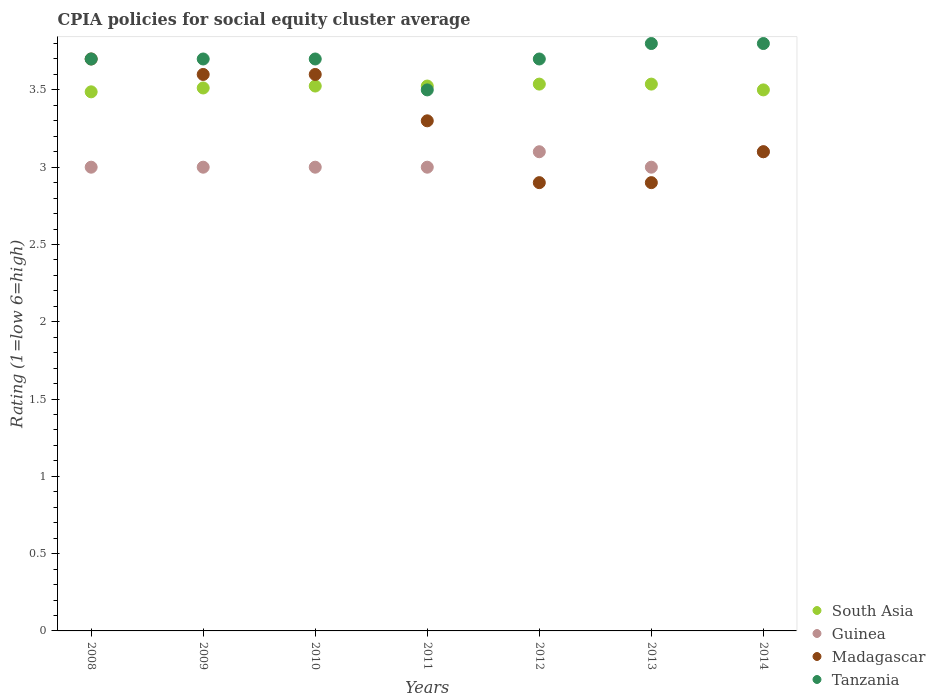Is the number of dotlines equal to the number of legend labels?
Offer a terse response. Yes. What is the CPIA rating in Tanzania in 2013?
Provide a succinct answer. 3.8. Across all years, what is the maximum CPIA rating in Tanzania?
Provide a succinct answer. 3.8. What is the total CPIA rating in Guinea in the graph?
Provide a short and direct response. 21.2. What is the difference between the CPIA rating in Madagascar in 2008 and that in 2010?
Give a very brief answer. 0.1. What is the difference between the CPIA rating in Madagascar in 2014 and the CPIA rating in Guinea in 2009?
Your response must be concise. 0.1. What is the average CPIA rating in Tanzania per year?
Your response must be concise. 3.7. In the year 2013, what is the difference between the CPIA rating in Madagascar and CPIA rating in South Asia?
Make the answer very short. -0.64. In how many years, is the CPIA rating in Madagascar greater than 3.3?
Give a very brief answer. 3. What is the ratio of the CPIA rating in Guinea in 2009 to that in 2012?
Offer a terse response. 0.97. Is the CPIA rating in Tanzania in 2010 less than that in 2012?
Keep it short and to the point. No. Is the difference between the CPIA rating in Madagascar in 2011 and 2013 greater than the difference between the CPIA rating in South Asia in 2011 and 2013?
Provide a succinct answer. Yes. What is the difference between the highest and the second highest CPIA rating in Madagascar?
Your response must be concise. 0.1. What is the difference between the highest and the lowest CPIA rating in Tanzania?
Make the answer very short. 0.3. In how many years, is the CPIA rating in Guinea greater than the average CPIA rating in Guinea taken over all years?
Offer a very short reply. 2. Is the sum of the CPIA rating in Madagascar in 2008 and 2010 greater than the maximum CPIA rating in Tanzania across all years?
Keep it short and to the point. Yes. Does the CPIA rating in South Asia monotonically increase over the years?
Your response must be concise. No. Is the CPIA rating in Guinea strictly less than the CPIA rating in Madagascar over the years?
Ensure brevity in your answer.  No. How many dotlines are there?
Your answer should be compact. 4. What is the difference between two consecutive major ticks on the Y-axis?
Make the answer very short. 0.5. Are the values on the major ticks of Y-axis written in scientific E-notation?
Provide a short and direct response. No. Where does the legend appear in the graph?
Make the answer very short. Bottom right. What is the title of the graph?
Make the answer very short. CPIA policies for social equity cluster average. Does "Low & middle income" appear as one of the legend labels in the graph?
Your response must be concise. No. What is the label or title of the X-axis?
Make the answer very short. Years. What is the label or title of the Y-axis?
Ensure brevity in your answer.  Rating (1=low 6=high). What is the Rating (1=low 6=high) in South Asia in 2008?
Provide a succinct answer. 3.49. What is the Rating (1=low 6=high) in Tanzania in 2008?
Your answer should be compact. 3.7. What is the Rating (1=low 6=high) in South Asia in 2009?
Keep it short and to the point. 3.51. What is the Rating (1=low 6=high) of Guinea in 2009?
Keep it short and to the point. 3. What is the Rating (1=low 6=high) in South Asia in 2010?
Make the answer very short. 3.52. What is the Rating (1=low 6=high) of Guinea in 2010?
Keep it short and to the point. 3. What is the Rating (1=low 6=high) of Tanzania in 2010?
Make the answer very short. 3.7. What is the Rating (1=low 6=high) in South Asia in 2011?
Your answer should be very brief. 3.52. What is the Rating (1=low 6=high) of Tanzania in 2011?
Your answer should be compact. 3.5. What is the Rating (1=low 6=high) of South Asia in 2012?
Offer a very short reply. 3.54. What is the Rating (1=low 6=high) of Guinea in 2012?
Your answer should be compact. 3.1. What is the Rating (1=low 6=high) in Madagascar in 2012?
Keep it short and to the point. 2.9. What is the Rating (1=low 6=high) in South Asia in 2013?
Your answer should be very brief. 3.54. What is the Rating (1=low 6=high) of Guinea in 2013?
Keep it short and to the point. 3. What is the Rating (1=low 6=high) in Madagascar in 2013?
Offer a very short reply. 2.9. What is the Rating (1=low 6=high) of Tanzania in 2013?
Your answer should be compact. 3.8. What is the Rating (1=low 6=high) in Madagascar in 2014?
Offer a terse response. 3.1. What is the Rating (1=low 6=high) in Tanzania in 2014?
Give a very brief answer. 3.8. Across all years, what is the maximum Rating (1=low 6=high) in South Asia?
Give a very brief answer. 3.54. Across all years, what is the maximum Rating (1=low 6=high) in Guinea?
Your answer should be compact. 3.1. Across all years, what is the minimum Rating (1=low 6=high) of South Asia?
Your answer should be very brief. 3.49. Across all years, what is the minimum Rating (1=low 6=high) in Tanzania?
Offer a terse response. 3.5. What is the total Rating (1=low 6=high) of South Asia in the graph?
Your answer should be very brief. 24.62. What is the total Rating (1=low 6=high) in Guinea in the graph?
Provide a succinct answer. 21.2. What is the total Rating (1=low 6=high) in Madagascar in the graph?
Your response must be concise. 23.1. What is the total Rating (1=low 6=high) of Tanzania in the graph?
Offer a very short reply. 25.9. What is the difference between the Rating (1=low 6=high) of South Asia in 2008 and that in 2009?
Offer a very short reply. -0.03. What is the difference between the Rating (1=low 6=high) in Madagascar in 2008 and that in 2009?
Make the answer very short. 0.1. What is the difference between the Rating (1=low 6=high) in South Asia in 2008 and that in 2010?
Offer a very short reply. -0.04. What is the difference between the Rating (1=low 6=high) in Guinea in 2008 and that in 2010?
Give a very brief answer. 0. What is the difference between the Rating (1=low 6=high) in Madagascar in 2008 and that in 2010?
Offer a very short reply. 0.1. What is the difference between the Rating (1=low 6=high) of Tanzania in 2008 and that in 2010?
Offer a terse response. 0. What is the difference between the Rating (1=low 6=high) in South Asia in 2008 and that in 2011?
Ensure brevity in your answer.  -0.04. What is the difference between the Rating (1=low 6=high) in Guinea in 2008 and that in 2012?
Give a very brief answer. -0.1. What is the difference between the Rating (1=low 6=high) of Tanzania in 2008 and that in 2012?
Provide a short and direct response. 0. What is the difference between the Rating (1=low 6=high) of Guinea in 2008 and that in 2013?
Offer a terse response. 0. What is the difference between the Rating (1=low 6=high) in South Asia in 2008 and that in 2014?
Give a very brief answer. -0.01. What is the difference between the Rating (1=low 6=high) in Guinea in 2008 and that in 2014?
Ensure brevity in your answer.  -0.1. What is the difference between the Rating (1=low 6=high) in South Asia in 2009 and that in 2010?
Your response must be concise. -0.01. What is the difference between the Rating (1=low 6=high) in Madagascar in 2009 and that in 2010?
Your response must be concise. 0. What is the difference between the Rating (1=low 6=high) in South Asia in 2009 and that in 2011?
Provide a short and direct response. -0.01. What is the difference between the Rating (1=low 6=high) of Guinea in 2009 and that in 2011?
Your answer should be compact. 0. What is the difference between the Rating (1=low 6=high) of Tanzania in 2009 and that in 2011?
Offer a terse response. 0.2. What is the difference between the Rating (1=low 6=high) in South Asia in 2009 and that in 2012?
Provide a succinct answer. -0.03. What is the difference between the Rating (1=low 6=high) of Madagascar in 2009 and that in 2012?
Offer a very short reply. 0.7. What is the difference between the Rating (1=low 6=high) of South Asia in 2009 and that in 2013?
Give a very brief answer. -0.03. What is the difference between the Rating (1=low 6=high) in Tanzania in 2009 and that in 2013?
Offer a terse response. -0.1. What is the difference between the Rating (1=low 6=high) of South Asia in 2009 and that in 2014?
Provide a short and direct response. 0.01. What is the difference between the Rating (1=low 6=high) of Madagascar in 2009 and that in 2014?
Your answer should be compact. 0.5. What is the difference between the Rating (1=low 6=high) of Tanzania in 2009 and that in 2014?
Offer a terse response. -0.1. What is the difference between the Rating (1=low 6=high) of Guinea in 2010 and that in 2011?
Give a very brief answer. 0. What is the difference between the Rating (1=low 6=high) in Madagascar in 2010 and that in 2011?
Provide a succinct answer. 0.3. What is the difference between the Rating (1=low 6=high) of South Asia in 2010 and that in 2012?
Your response must be concise. -0.01. What is the difference between the Rating (1=low 6=high) of Guinea in 2010 and that in 2012?
Your answer should be compact. -0.1. What is the difference between the Rating (1=low 6=high) of Tanzania in 2010 and that in 2012?
Offer a terse response. 0. What is the difference between the Rating (1=low 6=high) in South Asia in 2010 and that in 2013?
Your answer should be compact. -0.01. What is the difference between the Rating (1=low 6=high) of Madagascar in 2010 and that in 2013?
Give a very brief answer. 0.7. What is the difference between the Rating (1=low 6=high) of Tanzania in 2010 and that in 2013?
Offer a very short reply. -0.1. What is the difference between the Rating (1=low 6=high) in South Asia in 2010 and that in 2014?
Keep it short and to the point. 0.03. What is the difference between the Rating (1=low 6=high) of Guinea in 2010 and that in 2014?
Your response must be concise. -0.1. What is the difference between the Rating (1=low 6=high) in South Asia in 2011 and that in 2012?
Ensure brevity in your answer.  -0.01. What is the difference between the Rating (1=low 6=high) of Guinea in 2011 and that in 2012?
Offer a terse response. -0.1. What is the difference between the Rating (1=low 6=high) in Tanzania in 2011 and that in 2012?
Offer a very short reply. -0.2. What is the difference between the Rating (1=low 6=high) in South Asia in 2011 and that in 2013?
Your answer should be very brief. -0.01. What is the difference between the Rating (1=low 6=high) of Tanzania in 2011 and that in 2013?
Your response must be concise. -0.3. What is the difference between the Rating (1=low 6=high) in South Asia in 2011 and that in 2014?
Offer a very short reply. 0.03. What is the difference between the Rating (1=low 6=high) in Madagascar in 2011 and that in 2014?
Your answer should be very brief. 0.2. What is the difference between the Rating (1=low 6=high) in South Asia in 2012 and that in 2013?
Offer a terse response. 0. What is the difference between the Rating (1=low 6=high) in Madagascar in 2012 and that in 2013?
Offer a terse response. 0. What is the difference between the Rating (1=low 6=high) in Tanzania in 2012 and that in 2013?
Ensure brevity in your answer.  -0.1. What is the difference between the Rating (1=low 6=high) in South Asia in 2012 and that in 2014?
Your answer should be compact. 0.04. What is the difference between the Rating (1=low 6=high) in South Asia in 2013 and that in 2014?
Provide a succinct answer. 0.04. What is the difference between the Rating (1=low 6=high) of Guinea in 2013 and that in 2014?
Offer a very short reply. -0.1. What is the difference between the Rating (1=low 6=high) of Tanzania in 2013 and that in 2014?
Provide a succinct answer. 0. What is the difference between the Rating (1=low 6=high) of South Asia in 2008 and the Rating (1=low 6=high) of Guinea in 2009?
Provide a short and direct response. 0.49. What is the difference between the Rating (1=low 6=high) of South Asia in 2008 and the Rating (1=low 6=high) of Madagascar in 2009?
Ensure brevity in your answer.  -0.11. What is the difference between the Rating (1=low 6=high) of South Asia in 2008 and the Rating (1=low 6=high) of Tanzania in 2009?
Your response must be concise. -0.21. What is the difference between the Rating (1=low 6=high) in South Asia in 2008 and the Rating (1=low 6=high) in Guinea in 2010?
Ensure brevity in your answer.  0.49. What is the difference between the Rating (1=low 6=high) in South Asia in 2008 and the Rating (1=low 6=high) in Madagascar in 2010?
Ensure brevity in your answer.  -0.11. What is the difference between the Rating (1=low 6=high) in South Asia in 2008 and the Rating (1=low 6=high) in Tanzania in 2010?
Offer a very short reply. -0.21. What is the difference between the Rating (1=low 6=high) in Madagascar in 2008 and the Rating (1=low 6=high) in Tanzania in 2010?
Your response must be concise. 0. What is the difference between the Rating (1=low 6=high) of South Asia in 2008 and the Rating (1=low 6=high) of Guinea in 2011?
Offer a very short reply. 0.49. What is the difference between the Rating (1=low 6=high) of South Asia in 2008 and the Rating (1=low 6=high) of Madagascar in 2011?
Your answer should be very brief. 0.19. What is the difference between the Rating (1=low 6=high) of South Asia in 2008 and the Rating (1=low 6=high) of Tanzania in 2011?
Provide a short and direct response. -0.01. What is the difference between the Rating (1=low 6=high) in South Asia in 2008 and the Rating (1=low 6=high) in Guinea in 2012?
Your answer should be compact. 0.39. What is the difference between the Rating (1=low 6=high) of South Asia in 2008 and the Rating (1=low 6=high) of Madagascar in 2012?
Your response must be concise. 0.59. What is the difference between the Rating (1=low 6=high) of South Asia in 2008 and the Rating (1=low 6=high) of Tanzania in 2012?
Offer a very short reply. -0.21. What is the difference between the Rating (1=low 6=high) in South Asia in 2008 and the Rating (1=low 6=high) in Guinea in 2013?
Your answer should be compact. 0.49. What is the difference between the Rating (1=low 6=high) of South Asia in 2008 and the Rating (1=low 6=high) of Madagascar in 2013?
Your answer should be compact. 0.59. What is the difference between the Rating (1=low 6=high) in South Asia in 2008 and the Rating (1=low 6=high) in Tanzania in 2013?
Make the answer very short. -0.31. What is the difference between the Rating (1=low 6=high) in Guinea in 2008 and the Rating (1=low 6=high) in Madagascar in 2013?
Keep it short and to the point. 0.1. What is the difference between the Rating (1=low 6=high) of Madagascar in 2008 and the Rating (1=low 6=high) of Tanzania in 2013?
Give a very brief answer. -0.1. What is the difference between the Rating (1=low 6=high) in South Asia in 2008 and the Rating (1=low 6=high) in Guinea in 2014?
Your answer should be compact. 0.39. What is the difference between the Rating (1=low 6=high) of South Asia in 2008 and the Rating (1=low 6=high) of Madagascar in 2014?
Your response must be concise. 0.39. What is the difference between the Rating (1=low 6=high) in South Asia in 2008 and the Rating (1=low 6=high) in Tanzania in 2014?
Provide a succinct answer. -0.31. What is the difference between the Rating (1=low 6=high) of Guinea in 2008 and the Rating (1=low 6=high) of Madagascar in 2014?
Your answer should be very brief. -0.1. What is the difference between the Rating (1=low 6=high) in Guinea in 2008 and the Rating (1=low 6=high) in Tanzania in 2014?
Make the answer very short. -0.8. What is the difference between the Rating (1=low 6=high) in Madagascar in 2008 and the Rating (1=low 6=high) in Tanzania in 2014?
Your answer should be compact. -0.1. What is the difference between the Rating (1=low 6=high) in South Asia in 2009 and the Rating (1=low 6=high) in Guinea in 2010?
Your response must be concise. 0.51. What is the difference between the Rating (1=low 6=high) of South Asia in 2009 and the Rating (1=low 6=high) of Madagascar in 2010?
Your answer should be very brief. -0.09. What is the difference between the Rating (1=low 6=high) in South Asia in 2009 and the Rating (1=low 6=high) in Tanzania in 2010?
Your response must be concise. -0.19. What is the difference between the Rating (1=low 6=high) in South Asia in 2009 and the Rating (1=low 6=high) in Guinea in 2011?
Ensure brevity in your answer.  0.51. What is the difference between the Rating (1=low 6=high) in South Asia in 2009 and the Rating (1=low 6=high) in Madagascar in 2011?
Provide a succinct answer. 0.21. What is the difference between the Rating (1=low 6=high) in South Asia in 2009 and the Rating (1=low 6=high) in Tanzania in 2011?
Your response must be concise. 0.01. What is the difference between the Rating (1=low 6=high) in South Asia in 2009 and the Rating (1=low 6=high) in Guinea in 2012?
Ensure brevity in your answer.  0.41. What is the difference between the Rating (1=low 6=high) of South Asia in 2009 and the Rating (1=low 6=high) of Madagascar in 2012?
Your response must be concise. 0.61. What is the difference between the Rating (1=low 6=high) of South Asia in 2009 and the Rating (1=low 6=high) of Tanzania in 2012?
Your answer should be very brief. -0.19. What is the difference between the Rating (1=low 6=high) of Guinea in 2009 and the Rating (1=low 6=high) of Madagascar in 2012?
Offer a terse response. 0.1. What is the difference between the Rating (1=low 6=high) in Guinea in 2009 and the Rating (1=low 6=high) in Tanzania in 2012?
Keep it short and to the point. -0.7. What is the difference between the Rating (1=low 6=high) of Madagascar in 2009 and the Rating (1=low 6=high) of Tanzania in 2012?
Your answer should be compact. -0.1. What is the difference between the Rating (1=low 6=high) of South Asia in 2009 and the Rating (1=low 6=high) of Guinea in 2013?
Offer a very short reply. 0.51. What is the difference between the Rating (1=low 6=high) in South Asia in 2009 and the Rating (1=low 6=high) in Madagascar in 2013?
Give a very brief answer. 0.61. What is the difference between the Rating (1=low 6=high) in South Asia in 2009 and the Rating (1=low 6=high) in Tanzania in 2013?
Provide a short and direct response. -0.29. What is the difference between the Rating (1=low 6=high) of Guinea in 2009 and the Rating (1=low 6=high) of Madagascar in 2013?
Your answer should be compact. 0.1. What is the difference between the Rating (1=low 6=high) in Guinea in 2009 and the Rating (1=low 6=high) in Tanzania in 2013?
Give a very brief answer. -0.8. What is the difference between the Rating (1=low 6=high) of South Asia in 2009 and the Rating (1=low 6=high) of Guinea in 2014?
Your answer should be very brief. 0.41. What is the difference between the Rating (1=low 6=high) in South Asia in 2009 and the Rating (1=low 6=high) in Madagascar in 2014?
Provide a succinct answer. 0.41. What is the difference between the Rating (1=low 6=high) in South Asia in 2009 and the Rating (1=low 6=high) in Tanzania in 2014?
Offer a very short reply. -0.29. What is the difference between the Rating (1=low 6=high) of Guinea in 2009 and the Rating (1=low 6=high) of Madagascar in 2014?
Your response must be concise. -0.1. What is the difference between the Rating (1=low 6=high) in Madagascar in 2009 and the Rating (1=low 6=high) in Tanzania in 2014?
Your answer should be compact. -0.2. What is the difference between the Rating (1=low 6=high) of South Asia in 2010 and the Rating (1=low 6=high) of Guinea in 2011?
Offer a very short reply. 0.53. What is the difference between the Rating (1=low 6=high) of South Asia in 2010 and the Rating (1=low 6=high) of Madagascar in 2011?
Make the answer very short. 0.23. What is the difference between the Rating (1=low 6=high) of South Asia in 2010 and the Rating (1=low 6=high) of Tanzania in 2011?
Your answer should be compact. 0.03. What is the difference between the Rating (1=low 6=high) in Guinea in 2010 and the Rating (1=low 6=high) in Madagascar in 2011?
Offer a terse response. -0.3. What is the difference between the Rating (1=low 6=high) of Guinea in 2010 and the Rating (1=low 6=high) of Tanzania in 2011?
Make the answer very short. -0.5. What is the difference between the Rating (1=low 6=high) in Madagascar in 2010 and the Rating (1=low 6=high) in Tanzania in 2011?
Your answer should be compact. 0.1. What is the difference between the Rating (1=low 6=high) in South Asia in 2010 and the Rating (1=low 6=high) in Guinea in 2012?
Offer a terse response. 0.42. What is the difference between the Rating (1=low 6=high) in South Asia in 2010 and the Rating (1=low 6=high) in Madagascar in 2012?
Offer a very short reply. 0.62. What is the difference between the Rating (1=low 6=high) in South Asia in 2010 and the Rating (1=low 6=high) in Tanzania in 2012?
Keep it short and to the point. -0.17. What is the difference between the Rating (1=low 6=high) in Guinea in 2010 and the Rating (1=low 6=high) in Madagascar in 2012?
Offer a very short reply. 0.1. What is the difference between the Rating (1=low 6=high) of South Asia in 2010 and the Rating (1=low 6=high) of Guinea in 2013?
Ensure brevity in your answer.  0.53. What is the difference between the Rating (1=low 6=high) of South Asia in 2010 and the Rating (1=low 6=high) of Madagascar in 2013?
Provide a short and direct response. 0.62. What is the difference between the Rating (1=low 6=high) of South Asia in 2010 and the Rating (1=low 6=high) of Tanzania in 2013?
Offer a terse response. -0.28. What is the difference between the Rating (1=low 6=high) of Guinea in 2010 and the Rating (1=low 6=high) of Madagascar in 2013?
Offer a very short reply. 0.1. What is the difference between the Rating (1=low 6=high) of Guinea in 2010 and the Rating (1=low 6=high) of Tanzania in 2013?
Offer a very short reply. -0.8. What is the difference between the Rating (1=low 6=high) in South Asia in 2010 and the Rating (1=low 6=high) in Guinea in 2014?
Provide a succinct answer. 0.42. What is the difference between the Rating (1=low 6=high) of South Asia in 2010 and the Rating (1=low 6=high) of Madagascar in 2014?
Your answer should be compact. 0.42. What is the difference between the Rating (1=low 6=high) of South Asia in 2010 and the Rating (1=low 6=high) of Tanzania in 2014?
Keep it short and to the point. -0.28. What is the difference between the Rating (1=low 6=high) in Guinea in 2010 and the Rating (1=low 6=high) in Madagascar in 2014?
Keep it short and to the point. -0.1. What is the difference between the Rating (1=low 6=high) in Madagascar in 2010 and the Rating (1=low 6=high) in Tanzania in 2014?
Give a very brief answer. -0.2. What is the difference between the Rating (1=low 6=high) of South Asia in 2011 and the Rating (1=low 6=high) of Guinea in 2012?
Keep it short and to the point. 0.42. What is the difference between the Rating (1=low 6=high) in South Asia in 2011 and the Rating (1=low 6=high) in Tanzania in 2012?
Offer a terse response. -0.17. What is the difference between the Rating (1=low 6=high) of South Asia in 2011 and the Rating (1=low 6=high) of Guinea in 2013?
Provide a succinct answer. 0.53. What is the difference between the Rating (1=low 6=high) of South Asia in 2011 and the Rating (1=low 6=high) of Tanzania in 2013?
Offer a terse response. -0.28. What is the difference between the Rating (1=low 6=high) in Madagascar in 2011 and the Rating (1=low 6=high) in Tanzania in 2013?
Provide a short and direct response. -0.5. What is the difference between the Rating (1=low 6=high) of South Asia in 2011 and the Rating (1=low 6=high) of Guinea in 2014?
Provide a short and direct response. 0.42. What is the difference between the Rating (1=low 6=high) in South Asia in 2011 and the Rating (1=low 6=high) in Madagascar in 2014?
Offer a very short reply. 0.42. What is the difference between the Rating (1=low 6=high) of South Asia in 2011 and the Rating (1=low 6=high) of Tanzania in 2014?
Offer a very short reply. -0.28. What is the difference between the Rating (1=low 6=high) in Guinea in 2011 and the Rating (1=low 6=high) in Madagascar in 2014?
Your answer should be very brief. -0.1. What is the difference between the Rating (1=low 6=high) of Madagascar in 2011 and the Rating (1=low 6=high) of Tanzania in 2014?
Offer a very short reply. -0.5. What is the difference between the Rating (1=low 6=high) in South Asia in 2012 and the Rating (1=low 6=high) in Guinea in 2013?
Give a very brief answer. 0.54. What is the difference between the Rating (1=low 6=high) of South Asia in 2012 and the Rating (1=low 6=high) of Madagascar in 2013?
Ensure brevity in your answer.  0.64. What is the difference between the Rating (1=low 6=high) in South Asia in 2012 and the Rating (1=low 6=high) in Tanzania in 2013?
Provide a succinct answer. -0.26. What is the difference between the Rating (1=low 6=high) of South Asia in 2012 and the Rating (1=low 6=high) of Guinea in 2014?
Your answer should be compact. 0.44. What is the difference between the Rating (1=low 6=high) in South Asia in 2012 and the Rating (1=low 6=high) in Madagascar in 2014?
Ensure brevity in your answer.  0.44. What is the difference between the Rating (1=low 6=high) in South Asia in 2012 and the Rating (1=low 6=high) in Tanzania in 2014?
Offer a terse response. -0.26. What is the difference between the Rating (1=low 6=high) of Guinea in 2012 and the Rating (1=low 6=high) of Tanzania in 2014?
Your response must be concise. -0.7. What is the difference between the Rating (1=low 6=high) of South Asia in 2013 and the Rating (1=low 6=high) of Guinea in 2014?
Provide a succinct answer. 0.44. What is the difference between the Rating (1=low 6=high) in South Asia in 2013 and the Rating (1=low 6=high) in Madagascar in 2014?
Offer a very short reply. 0.44. What is the difference between the Rating (1=low 6=high) in South Asia in 2013 and the Rating (1=low 6=high) in Tanzania in 2014?
Offer a very short reply. -0.26. What is the difference between the Rating (1=low 6=high) in Guinea in 2013 and the Rating (1=low 6=high) in Tanzania in 2014?
Your answer should be compact. -0.8. What is the average Rating (1=low 6=high) in South Asia per year?
Your answer should be very brief. 3.52. What is the average Rating (1=low 6=high) of Guinea per year?
Provide a short and direct response. 3.03. In the year 2008, what is the difference between the Rating (1=low 6=high) in South Asia and Rating (1=low 6=high) in Guinea?
Provide a short and direct response. 0.49. In the year 2008, what is the difference between the Rating (1=low 6=high) in South Asia and Rating (1=low 6=high) in Madagascar?
Provide a succinct answer. -0.21. In the year 2008, what is the difference between the Rating (1=low 6=high) in South Asia and Rating (1=low 6=high) in Tanzania?
Ensure brevity in your answer.  -0.21. In the year 2008, what is the difference between the Rating (1=low 6=high) of Guinea and Rating (1=low 6=high) of Madagascar?
Make the answer very short. -0.7. In the year 2008, what is the difference between the Rating (1=low 6=high) in Guinea and Rating (1=low 6=high) in Tanzania?
Your answer should be compact. -0.7. In the year 2008, what is the difference between the Rating (1=low 6=high) in Madagascar and Rating (1=low 6=high) in Tanzania?
Ensure brevity in your answer.  0. In the year 2009, what is the difference between the Rating (1=low 6=high) of South Asia and Rating (1=low 6=high) of Guinea?
Your answer should be compact. 0.51. In the year 2009, what is the difference between the Rating (1=low 6=high) in South Asia and Rating (1=low 6=high) in Madagascar?
Offer a terse response. -0.09. In the year 2009, what is the difference between the Rating (1=low 6=high) of South Asia and Rating (1=low 6=high) of Tanzania?
Provide a short and direct response. -0.19. In the year 2009, what is the difference between the Rating (1=low 6=high) of Guinea and Rating (1=low 6=high) of Madagascar?
Offer a terse response. -0.6. In the year 2009, what is the difference between the Rating (1=low 6=high) of Guinea and Rating (1=low 6=high) of Tanzania?
Your answer should be compact. -0.7. In the year 2009, what is the difference between the Rating (1=low 6=high) of Madagascar and Rating (1=low 6=high) of Tanzania?
Your response must be concise. -0.1. In the year 2010, what is the difference between the Rating (1=low 6=high) of South Asia and Rating (1=low 6=high) of Guinea?
Offer a very short reply. 0.53. In the year 2010, what is the difference between the Rating (1=low 6=high) of South Asia and Rating (1=low 6=high) of Madagascar?
Ensure brevity in your answer.  -0.07. In the year 2010, what is the difference between the Rating (1=low 6=high) of South Asia and Rating (1=low 6=high) of Tanzania?
Give a very brief answer. -0.17. In the year 2010, what is the difference between the Rating (1=low 6=high) of Guinea and Rating (1=low 6=high) of Madagascar?
Your answer should be very brief. -0.6. In the year 2010, what is the difference between the Rating (1=low 6=high) in Guinea and Rating (1=low 6=high) in Tanzania?
Make the answer very short. -0.7. In the year 2011, what is the difference between the Rating (1=low 6=high) of South Asia and Rating (1=low 6=high) of Guinea?
Provide a short and direct response. 0.53. In the year 2011, what is the difference between the Rating (1=low 6=high) of South Asia and Rating (1=low 6=high) of Madagascar?
Provide a succinct answer. 0.23. In the year 2011, what is the difference between the Rating (1=low 6=high) in South Asia and Rating (1=low 6=high) in Tanzania?
Give a very brief answer. 0.03. In the year 2011, what is the difference between the Rating (1=low 6=high) of Madagascar and Rating (1=low 6=high) of Tanzania?
Provide a short and direct response. -0.2. In the year 2012, what is the difference between the Rating (1=low 6=high) of South Asia and Rating (1=low 6=high) of Guinea?
Offer a very short reply. 0.44. In the year 2012, what is the difference between the Rating (1=low 6=high) in South Asia and Rating (1=low 6=high) in Madagascar?
Give a very brief answer. 0.64. In the year 2012, what is the difference between the Rating (1=low 6=high) of South Asia and Rating (1=low 6=high) of Tanzania?
Keep it short and to the point. -0.16. In the year 2012, what is the difference between the Rating (1=low 6=high) in Madagascar and Rating (1=low 6=high) in Tanzania?
Offer a very short reply. -0.8. In the year 2013, what is the difference between the Rating (1=low 6=high) of South Asia and Rating (1=low 6=high) of Guinea?
Ensure brevity in your answer.  0.54. In the year 2013, what is the difference between the Rating (1=low 6=high) of South Asia and Rating (1=low 6=high) of Madagascar?
Offer a terse response. 0.64. In the year 2013, what is the difference between the Rating (1=low 6=high) of South Asia and Rating (1=low 6=high) of Tanzania?
Make the answer very short. -0.26. In the year 2013, what is the difference between the Rating (1=low 6=high) in Guinea and Rating (1=low 6=high) in Madagascar?
Offer a very short reply. 0.1. In the year 2014, what is the difference between the Rating (1=low 6=high) of South Asia and Rating (1=low 6=high) of Guinea?
Your answer should be very brief. 0.4. In the year 2014, what is the difference between the Rating (1=low 6=high) of South Asia and Rating (1=low 6=high) of Tanzania?
Ensure brevity in your answer.  -0.3. In the year 2014, what is the difference between the Rating (1=low 6=high) of Guinea and Rating (1=low 6=high) of Madagascar?
Give a very brief answer. 0. In the year 2014, what is the difference between the Rating (1=low 6=high) of Guinea and Rating (1=low 6=high) of Tanzania?
Your answer should be very brief. -0.7. What is the ratio of the Rating (1=low 6=high) in South Asia in 2008 to that in 2009?
Your response must be concise. 0.99. What is the ratio of the Rating (1=low 6=high) in Guinea in 2008 to that in 2009?
Your answer should be compact. 1. What is the ratio of the Rating (1=low 6=high) in Madagascar in 2008 to that in 2009?
Offer a terse response. 1.03. What is the ratio of the Rating (1=low 6=high) in Tanzania in 2008 to that in 2009?
Your response must be concise. 1. What is the ratio of the Rating (1=low 6=high) of Guinea in 2008 to that in 2010?
Provide a succinct answer. 1. What is the ratio of the Rating (1=low 6=high) of Madagascar in 2008 to that in 2010?
Keep it short and to the point. 1.03. What is the ratio of the Rating (1=low 6=high) in Madagascar in 2008 to that in 2011?
Give a very brief answer. 1.12. What is the ratio of the Rating (1=low 6=high) in Tanzania in 2008 to that in 2011?
Provide a short and direct response. 1.06. What is the ratio of the Rating (1=low 6=high) of South Asia in 2008 to that in 2012?
Make the answer very short. 0.99. What is the ratio of the Rating (1=low 6=high) of Guinea in 2008 to that in 2012?
Your answer should be very brief. 0.97. What is the ratio of the Rating (1=low 6=high) of Madagascar in 2008 to that in 2012?
Make the answer very short. 1.28. What is the ratio of the Rating (1=low 6=high) in South Asia in 2008 to that in 2013?
Give a very brief answer. 0.99. What is the ratio of the Rating (1=low 6=high) of Guinea in 2008 to that in 2013?
Offer a very short reply. 1. What is the ratio of the Rating (1=low 6=high) of Madagascar in 2008 to that in 2013?
Make the answer very short. 1.28. What is the ratio of the Rating (1=low 6=high) in Tanzania in 2008 to that in 2013?
Offer a terse response. 0.97. What is the ratio of the Rating (1=low 6=high) in Guinea in 2008 to that in 2014?
Provide a short and direct response. 0.97. What is the ratio of the Rating (1=low 6=high) in Madagascar in 2008 to that in 2014?
Your answer should be compact. 1.19. What is the ratio of the Rating (1=low 6=high) of Tanzania in 2008 to that in 2014?
Provide a succinct answer. 0.97. What is the ratio of the Rating (1=low 6=high) in South Asia in 2009 to that in 2010?
Provide a succinct answer. 1. What is the ratio of the Rating (1=low 6=high) of Madagascar in 2009 to that in 2010?
Ensure brevity in your answer.  1. What is the ratio of the Rating (1=low 6=high) in South Asia in 2009 to that in 2011?
Ensure brevity in your answer.  1. What is the ratio of the Rating (1=low 6=high) of Madagascar in 2009 to that in 2011?
Provide a short and direct response. 1.09. What is the ratio of the Rating (1=low 6=high) of Tanzania in 2009 to that in 2011?
Your answer should be very brief. 1.06. What is the ratio of the Rating (1=low 6=high) of Guinea in 2009 to that in 2012?
Provide a short and direct response. 0.97. What is the ratio of the Rating (1=low 6=high) of Madagascar in 2009 to that in 2012?
Offer a terse response. 1.24. What is the ratio of the Rating (1=low 6=high) in Guinea in 2009 to that in 2013?
Offer a terse response. 1. What is the ratio of the Rating (1=low 6=high) of Madagascar in 2009 to that in 2013?
Your answer should be compact. 1.24. What is the ratio of the Rating (1=low 6=high) of Tanzania in 2009 to that in 2013?
Provide a succinct answer. 0.97. What is the ratio of the Rating (1=low 6=high) of Guinea in 2009 to that in 2014?
Provide a succinct answer. 0.97. What is the ratio of the Rating (1=low 6=high) of Madagascar in 2009 to that in 2014?
Make the answer very short. 1.16. What is the ratio of the Rating (1=low 6=high) of Tanzania in 2009 to that in 2014?
Provide a succinct answer. 0.97. What is the ratio of the Rating (1=low 6=high) of South Asia in 2010 to that in 2011?
Your answer should be very brief. 1. What is the ratio of the Rating (1=low 6=high) in Tanzania in 2010 to that in 2011?
Give a very brief answer. 1.06. What is the ratio of the Rating (1=low 6=high) of Guinea in 2010 to that in 2012?
Offer a very short reply. 0.97. What is the ratio of the Rating (1=low 6=high) of Madagascar in 2010 to that in 2012?
Ensure brevity in your answer.  1.24. What is the ratio of the Rating (1=low 6=high) of South Asia in 2010 to that in 2013?
Your response must be concise. 1. What is the ratio of the Rating (1=low 6=high) of Madagascar in 2010 to that in 2013?
Your answer should be very brief. 1.24. What is the ratio of the Rating (1=low 6=high) in Tanzania in 2010 to that in 2013?
Give a very brief answer. 0.97. What is the ratio of the Rating (1=low 6=high) of South Asia in 2010 to that in 2014?
Your response must be concise. 1.01. What is the ratio of the Rating (1=low 6=high) of Madagascar in 2010 to that in 2014?
Make the answer very short. 1.16. What is the ratio of the Rating (1=low 6=high) in Tanzania in 2010 to that in 2014?
Your answer should be compact. 0.97. What is the ratio of the Rating (1=low 6=high) in South Asia in 2011 to that in 2012?
Your response must be concise. 1. What is the ratio of the Rating (1=low 6=high) in Guinea in 2011 to that in 2012?
Offer a terse response. 0.97. What is the ratio of the Rating (1=low 6=high) of Madagascar in 2011 to that in 2012?
Make the answer very short. 1.14. What is the ratio of the Rating (1=low 6=high) of Tanzania in 2011 to that in 2012?
Provide a succinct answer. 0.95. What is the ratio of the Rating (1=low 6=high) of Guinea in 2011 to that in 2013?
Keep it short and to the point. 1. What is the ratio of the Rating (1=low 6=high) of Madagascar in 2011 to that in 2013?
Your answer should be very brief. 1.14. What is the ratio of the Rating (1=low 6=high) in Tanzania in 2011 to that in 2013?
Your answer should be compact. 0.92. What is the ratio of the Rating (1=low 6=high) of South Asia in 2011 to that in 2014?
Your answer should be very brief. 1.01. What is the ratio of the Rating (1=low 6=high) in Madagascar in 2011 to that in 2014?
Offer a very short reply. 1.06. What is the ratio of the Rating (1=low 6=high) in Tanzania in 2011 to that in 2014?
Keep it short and to the point. 0.92. What is the ratio of the Rating (1=low 6=high) in Madagascar in 2012 to that in 2013?
Provide a succinct answer. 1. What is the ratio of the Rating (1=low 6=high) of Tanzania in 2012 to that in 2013?
Your answer should be compact. 0.97. What is the ratio of the Rating (1=low 6=high) in South Asia in 2012 to that in 2014?
Give a very brief answer. 1.01. What is the ratio of the Rating (1=low 6=high) of Madagascar in 2012 to that in 2014?
Offer a very short reply. 0.94. What is the ratio of the Rating (1=low 6=high) of Tanzania in 2012 to that in 2014?
Your answer should be compact. 0.97. What is the ratio of the Rating (1=low 6=high) in South Asia in 2013 to that in 2014?
Provide a succinct answer. 1.01. What is the ratio of the Rating (1=low 6=high) of Madagascar in 2013 to that in 2014?
Your answer should be very brief. 0.94. What is the difference between the highest and the second highest Rating (1=low 6=high) of Madagascar?
Your response must be concise. 0.1. What is the difference between the highest and the lowest Rating (1=low 6=high) of South Asia?
Offer a very short reply. 0.05. What is the difference between the highest and the lowest Rating (1=low 6=high) in Tanzania?
Your answer should be very brief. 0.3. 